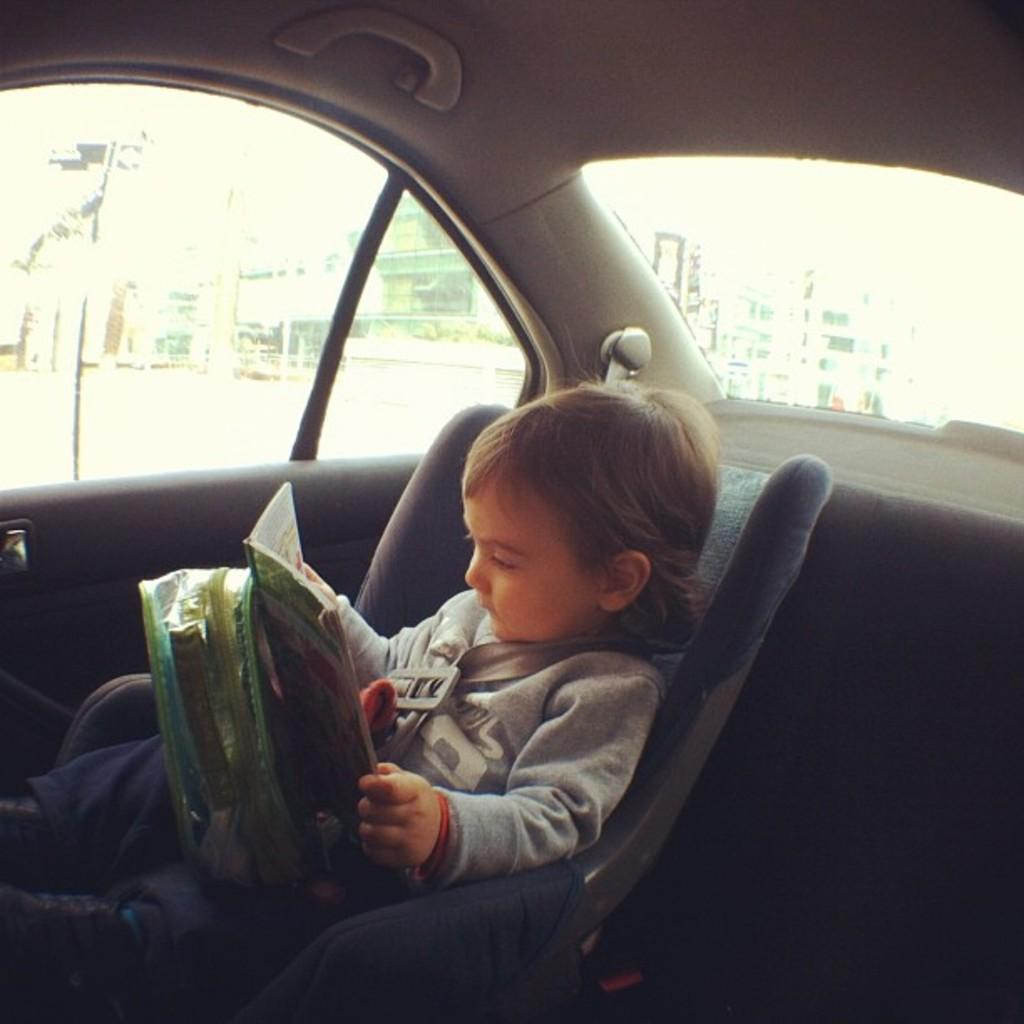What type of structure is visible in the image? There is a building in the image. What can be seen near the building? There is a traffic signal in the image. Who is present in the car in the image? There is a child sitting in the car. What is the child holding in their hands? The child is holding a book and a bag. What scientific discovery is the child making in the image? There is no indication of a scientific discovery being made in the image. The child is simply sitting in a car holding a book and a bag. 